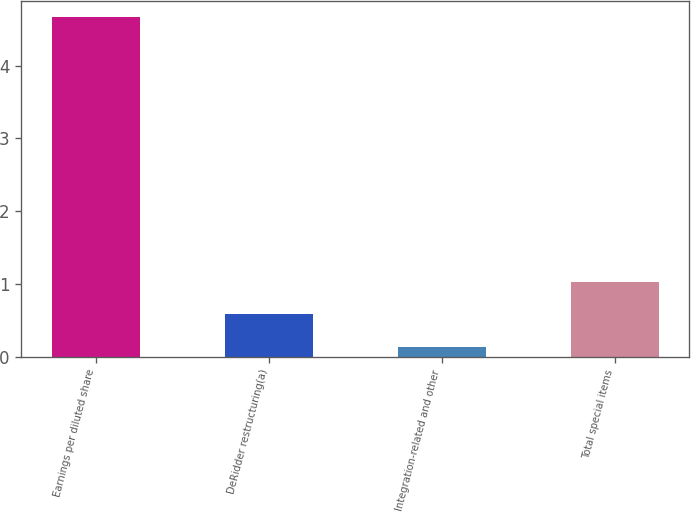Convert chart to OTSL. <chart><loc_0><loc_0><loc_500><loc_500><bar_chart><fcel>Earnings per diluted share<fcel>DeRidder restructuring(a)<fcel>Integration-related and other<fcel>Total special items<nl><fcel>4.66<fcel>0.58<fcel>0.13<fcel>1.03<nl></chart> 